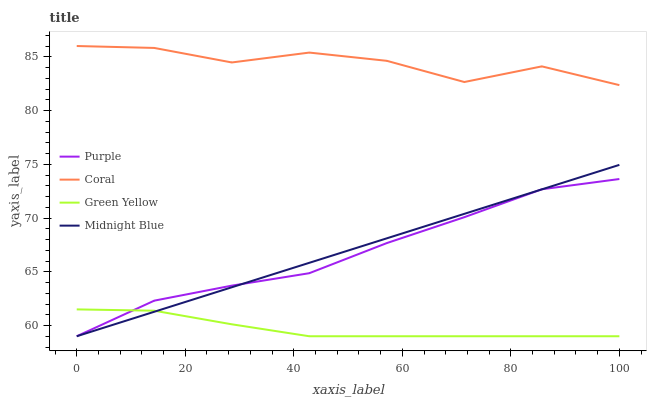Does Green Yellow have the minimum area under the curve?
Answer yes or no. Yes. Does Coral have the maximum area under the curve?
Answer yes or no. Yes. Does Coral have the minimum area under the curve?
Answer yes or no. No. Does Green Yellow have the maximum area under the curve?
Answer yes or no. No. Is Midnight Blue the smoothest?
Answer yes or no. Yes. Is Coral the roughest?
Answer yes or no. Yes. Is Green Yellow the smoothest?
Answer yes or no. No. Is Green Yellow the roughest?
Answer yes or no. No. Does Purple have the lowest value?
Answer yes or no. Yes. Does Coral have the lowest value?
Answer yes or no. No. Does Coral have the highest value?
Answer yes or no. Yes. Does Green Yellow have the highest value?
Answer yes or no. No. Is Midnight Blue less than Coral?
Answer yes or no. Yes. Is Coral greater than Green Yellow?
Answer yes or no. Yes. Does Purple intersect Green Yellow?
Answer yes or no. Yes. Is Purple less than Green Yellow?
Answer yes or no. No. Is Purple greater than Green Yellow?
Answer yes or no. No. Does Midnight Blue intersect Coral?
Answer yes or no. No. 